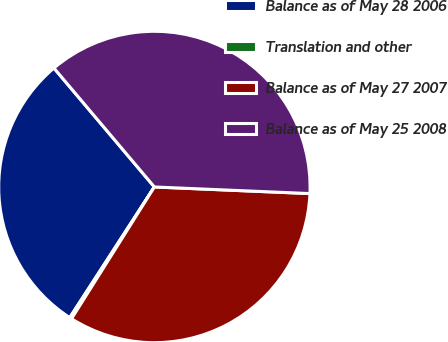<chart> <loc_0><loc_0><loc_500><loc_500><pie_chart><fcel>Balance as of May 28 2006<fcel>Translation and other<fcel>Balance as of May 27 2007<fcel>Balance as of May 25 2008<nl><fcel>29.69%<fcel>0.21%<fcel>33.26%<fcel>36.84%<nl></chart> 